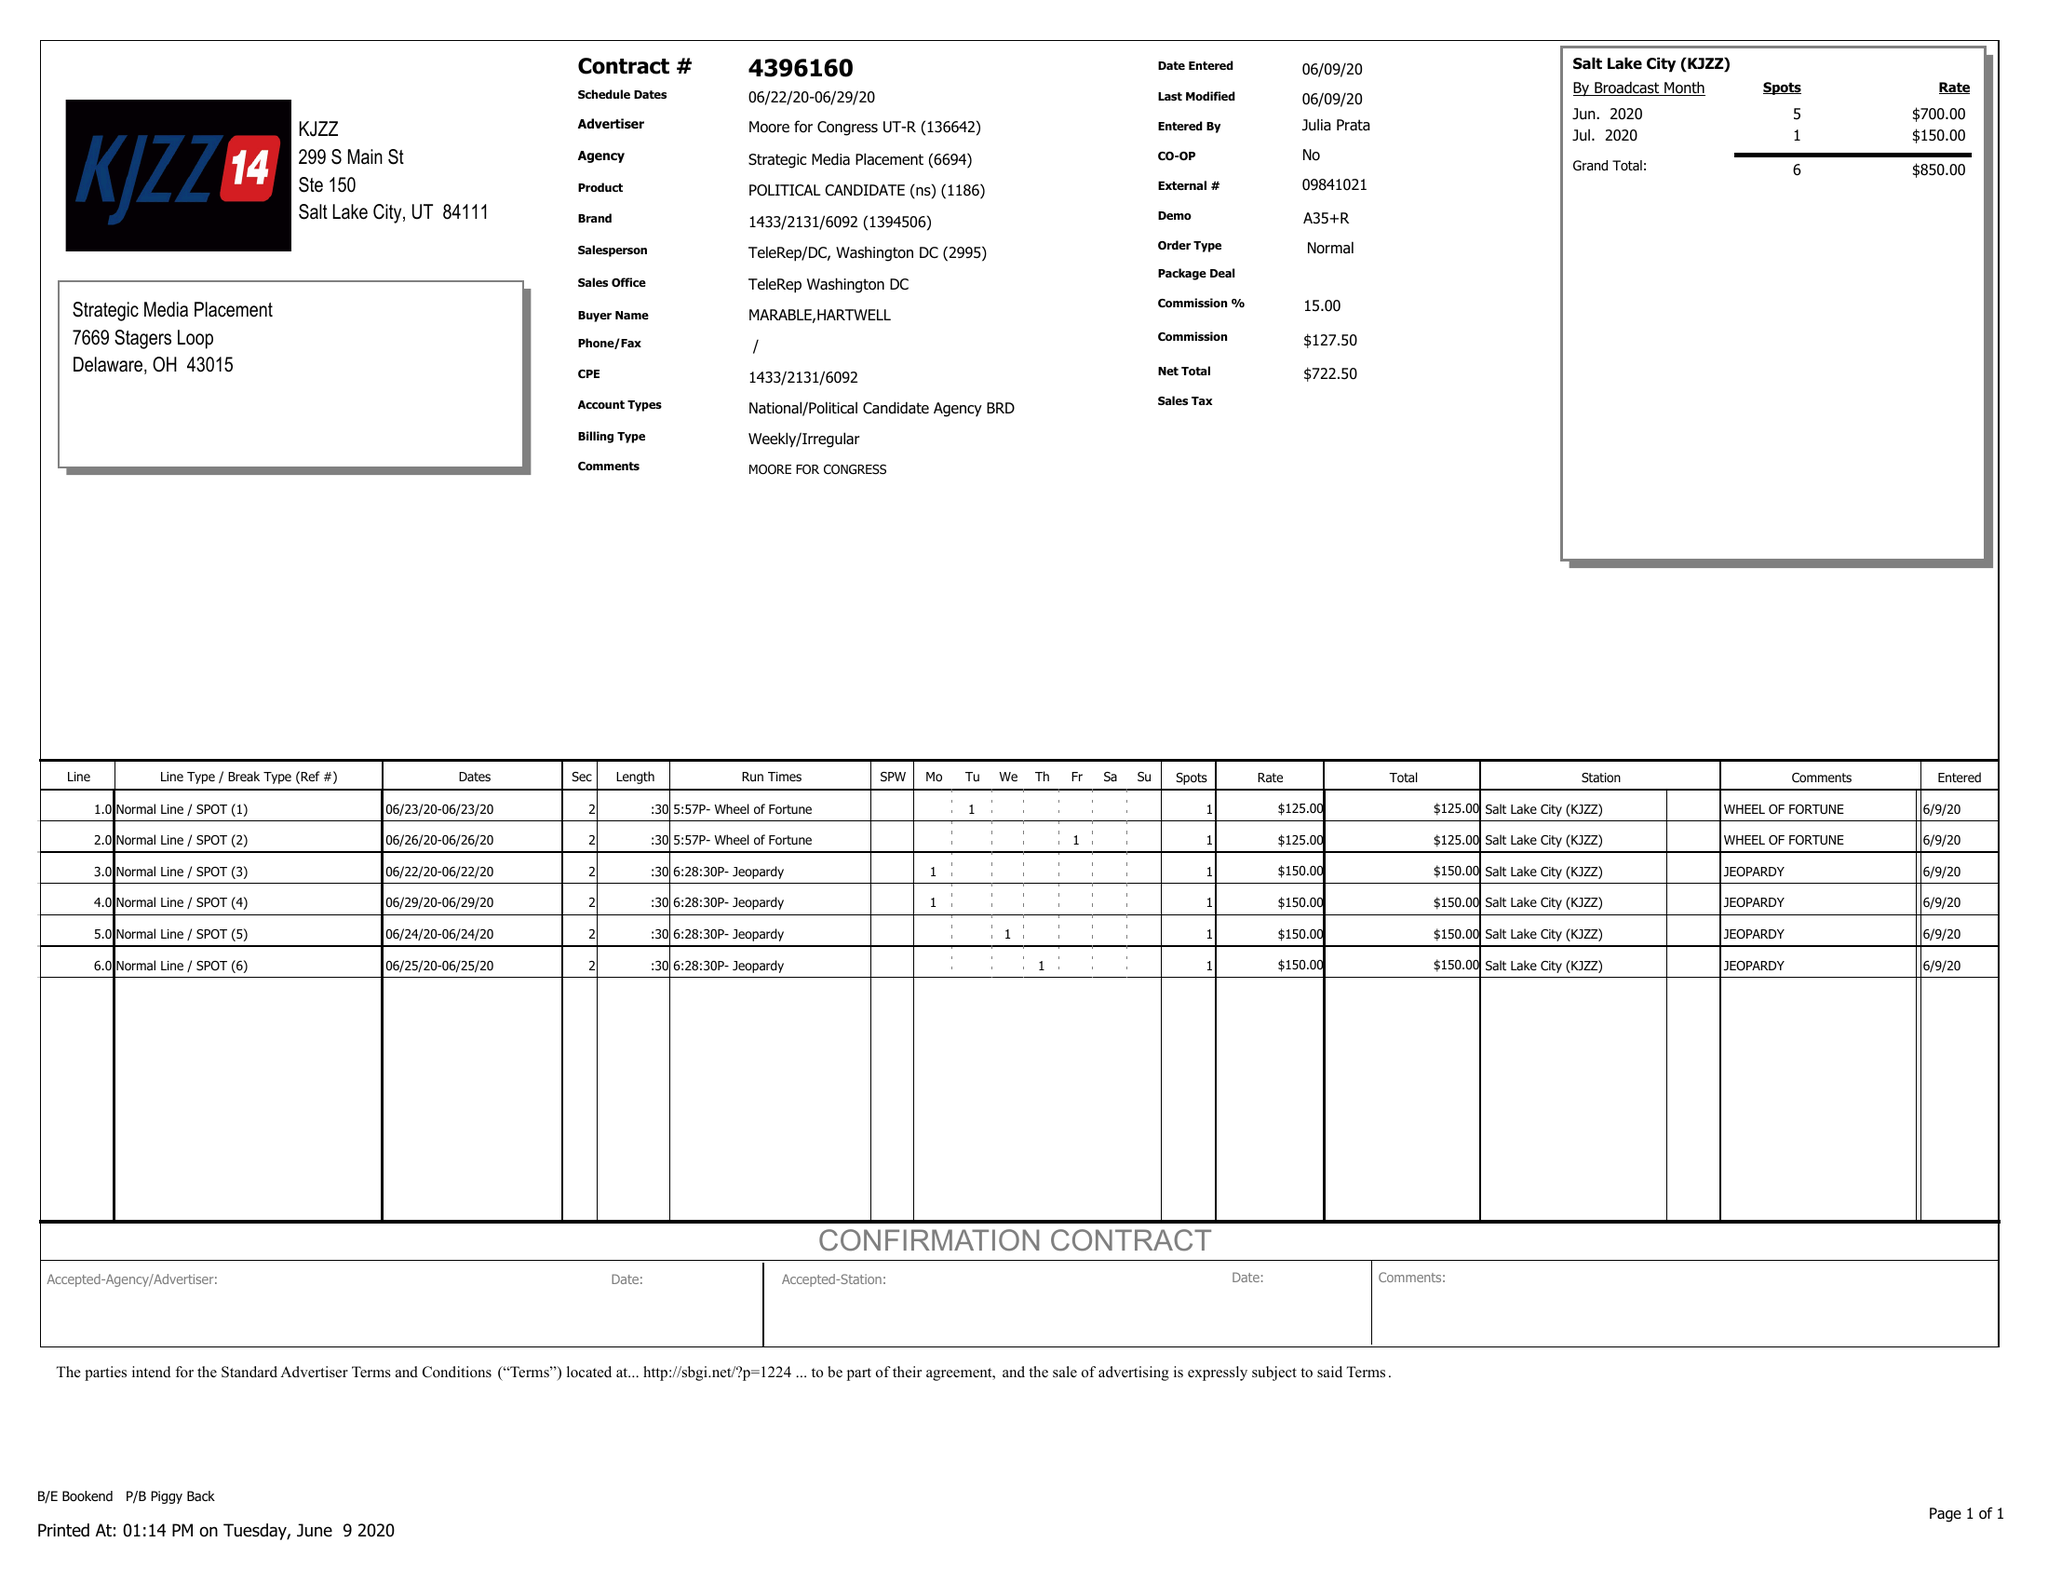What is the value for the advertiser?
Answer the question using a single word or phrase. MOORE FOR CONGRESS UT-R 